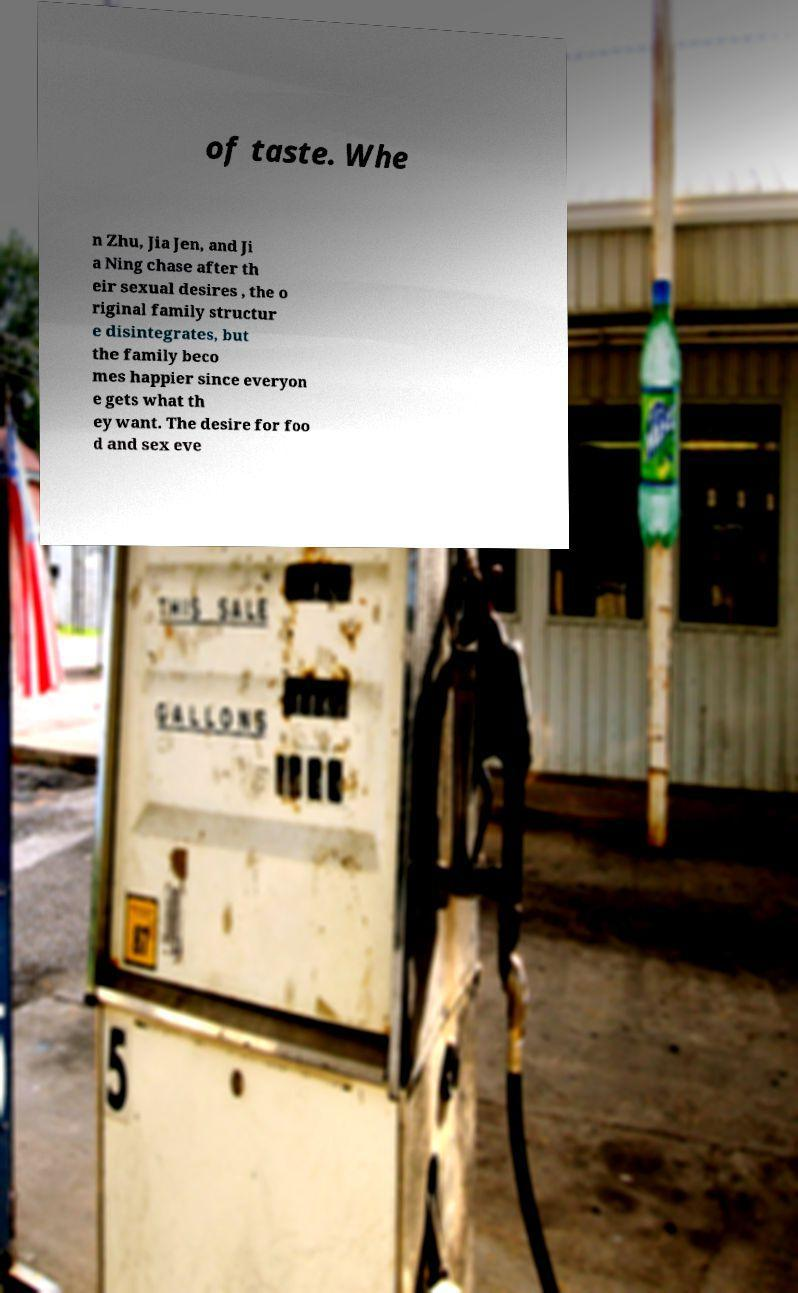Please identify and transcribe the text found in this image. of taste. Whe n Zhu, Jia Jen, and Ji a Ning chase after th eir sexual desires , the o riginal family structur e disintegrates, but the family beco mes happier since everyon e gets what th ey want. The desire for foo d and sex eve 